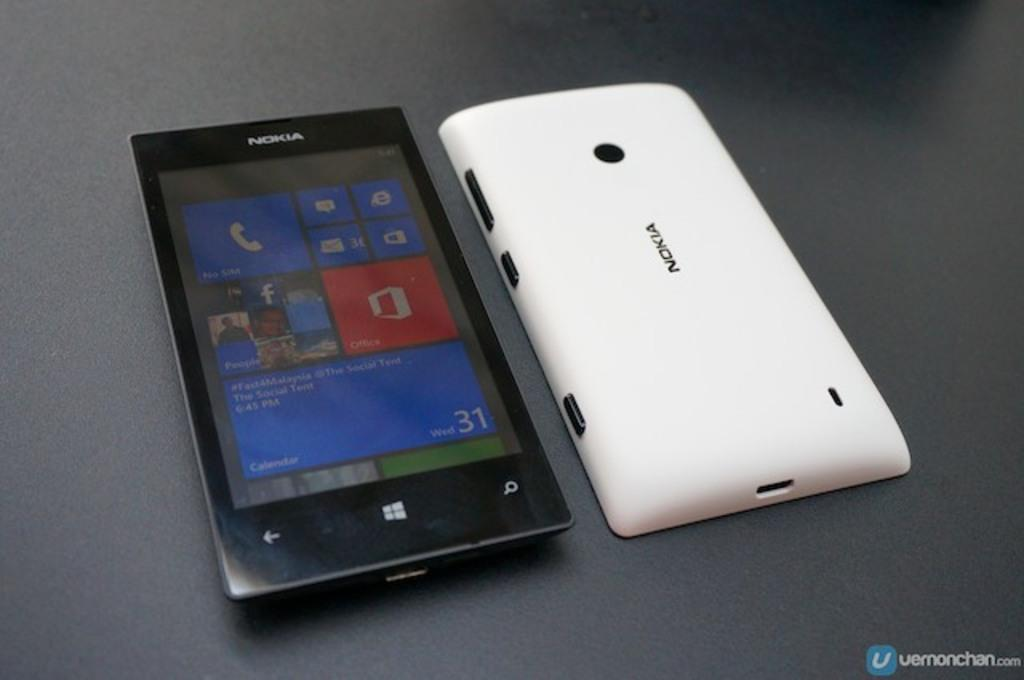<image>
Share a concise interpretation of the image provided. The front and back of a nokia cell phone is displayed. 